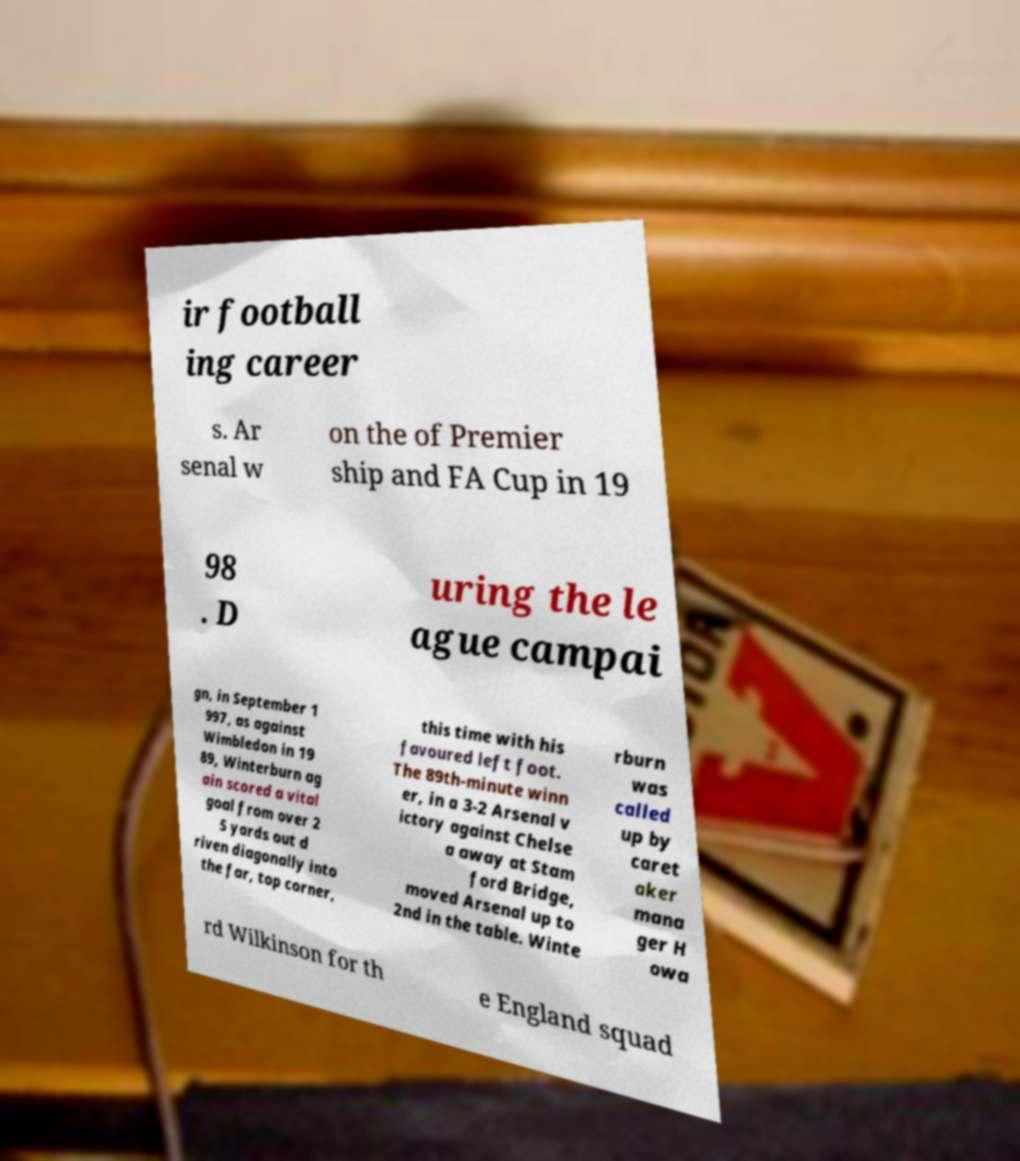Can you read and provide the text displayed in the image?This photo seems to have some interesting text. Can you extract and type it out for me? ir football ing career s. Ar senal w on the of Premier ship and FA Cup in 19 98 . D uring the le ague campai gn, in September 1 997, as against Wimbledon in 19 89, Winterburn ag ain scored a vital goal from over 2 5 yards out d riven diagonally into the far, top corner, this time with his favoured left foot. The 89th-minute winn er, in a 3-2 Arsenal v ictory against Chelse a away at Stam ford Bridge, moved Arsenal up to 2nd in the table. Winte rburn was called up by caret aker mana ger H owa rd Wilkinson for th e England squad 